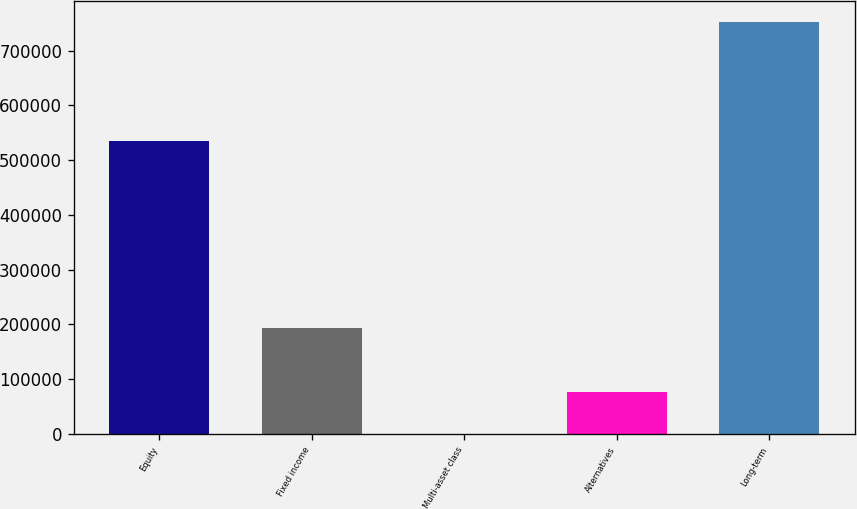Convert chart to OTSL. <chart><loc_0><loc_0><loc_500><loc_500><bar_chart><fcel>Equity<fcel>Fixed income<fcel>Multi-asset class<fcel>Alternatives<fcel>Long-term<nl><fcel>534648<fcel>192852<fcel>869<fcel>76052.8<fcel>752707<nl></chart> 